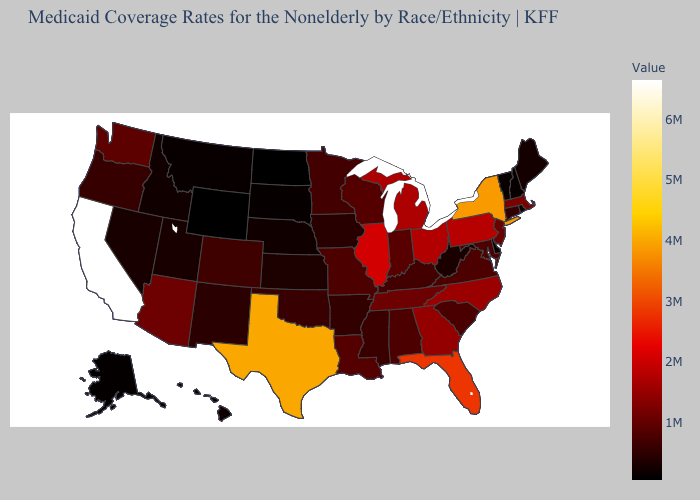Does Nebraska have the lowest value in the MidWest?
Keep it brief. No. Does Wyoming have the lowest value in the USA?
Concise answer only. Yes. Which states hav the highest value in the West?
Short answer required. California. Does the map have missing data?
Be succinct. No. Among the states that border West Virginia , does Pennsylvania have the highest value?
Concise answer only. Yes. Does Wyoming have the lowest value in the USA?
Keep it brief. Yes. 